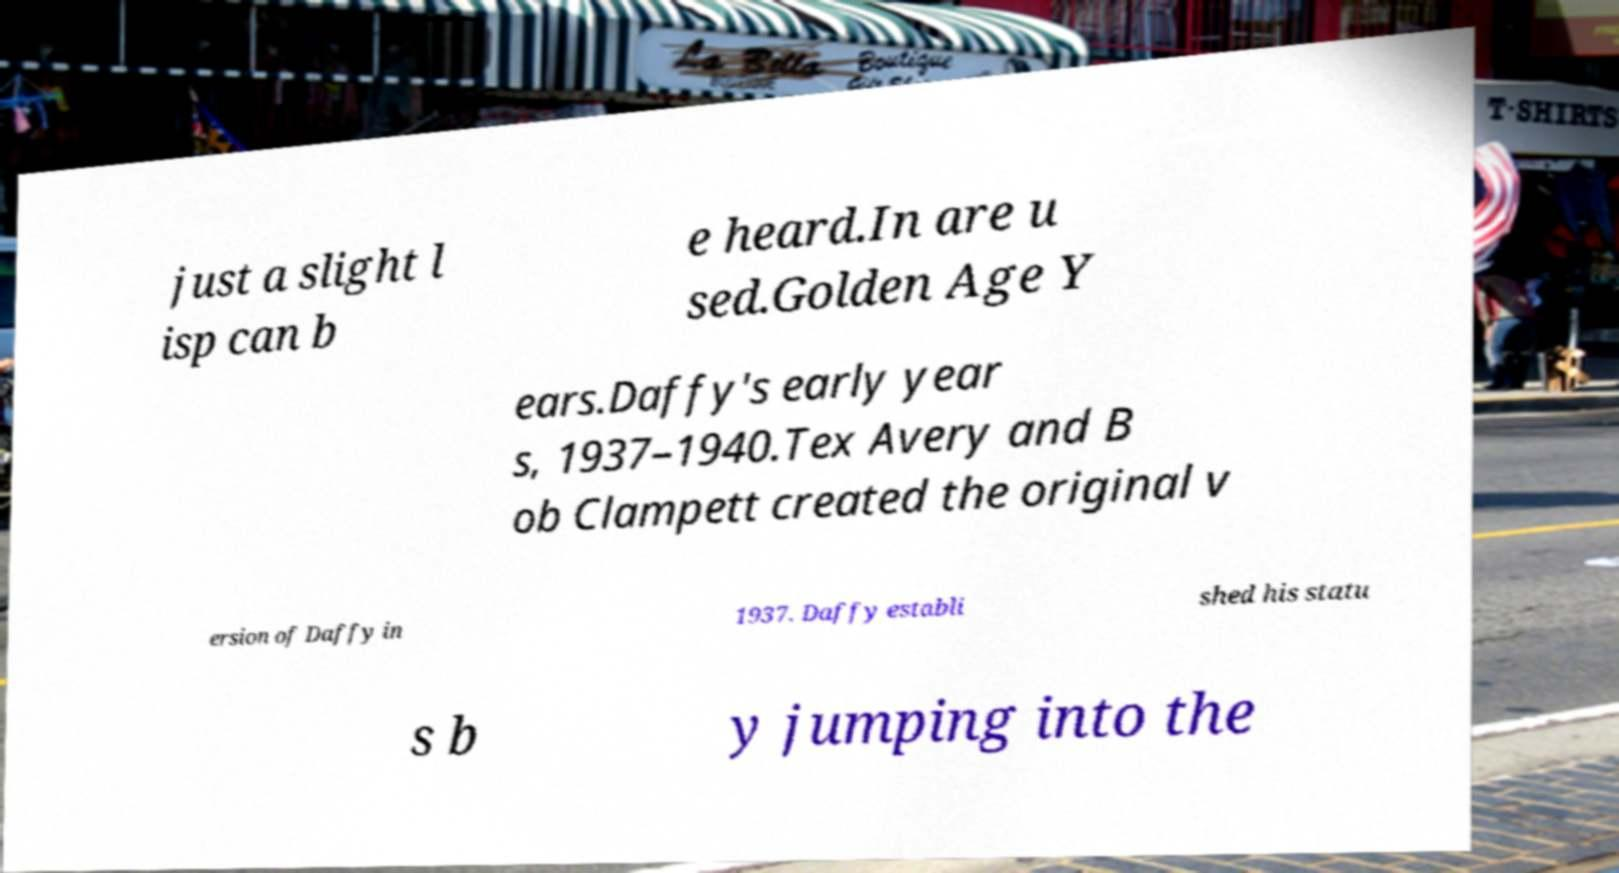Please identify and transcribe the text found in this image. just a slight l isp can b e heard.In are u sed.Golden Age Y ears.Daffy's early year s, 1937–1940.Tex Avery and B ob Clampett created the original v ersion of Daffy in 1937. Daffy establi shed his statu s b y jumping into the 